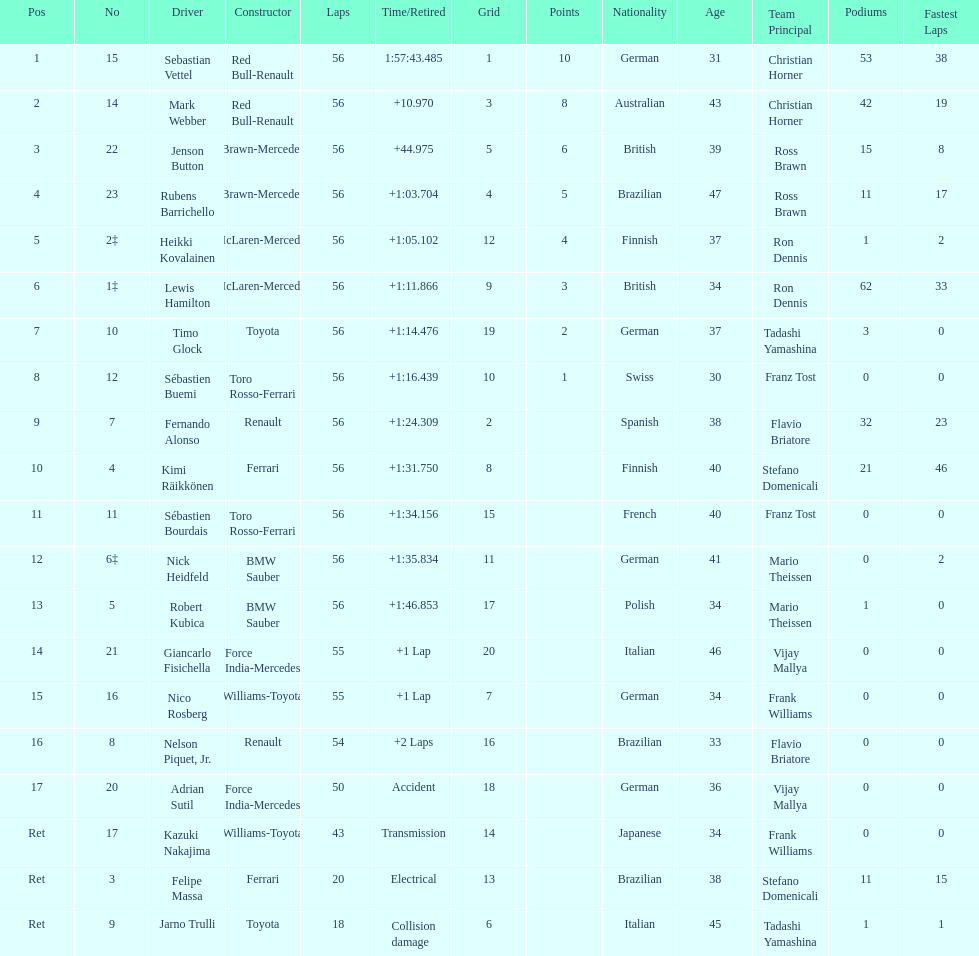What name is just previous to kazuki nakjima on the list? Adrian Sutil. 